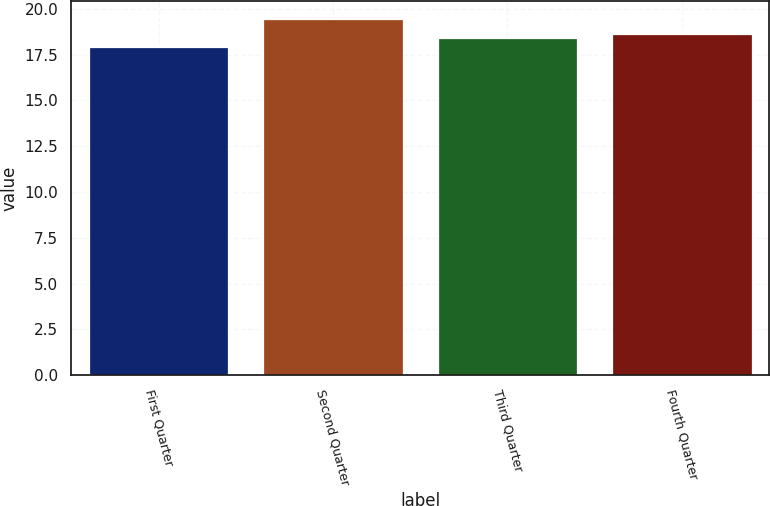Convert chart. <chart><loc_0><loc_0><loc_500><loc_500><bar_chart><fcel>First Quarter<fcel>Second Quarter<fcel>Third Quarter<fcel>Fourth Quarter<nl><fcel>17.9<fcel>19.45<fcel>18.4<fcel>18.64<nl></chart> 